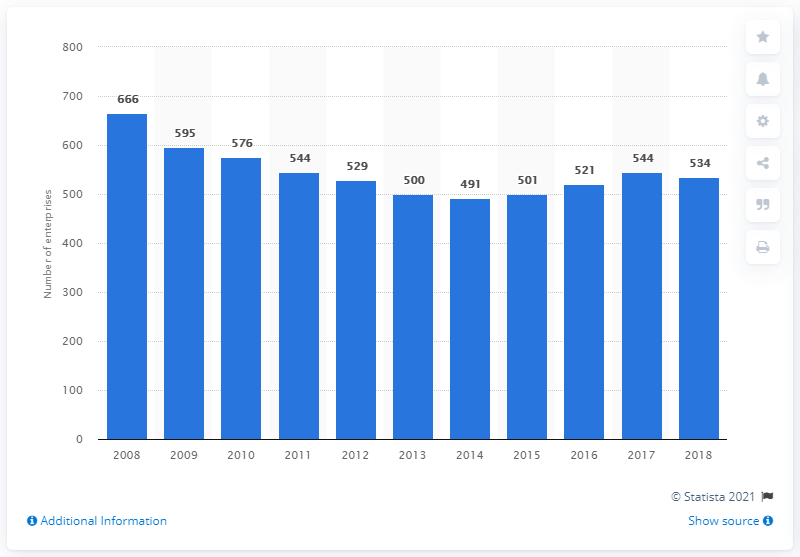Give some essential details in this illustration. There were 501 enterprises in the manufacture of leather and related products industry in Hungary in 2015. 